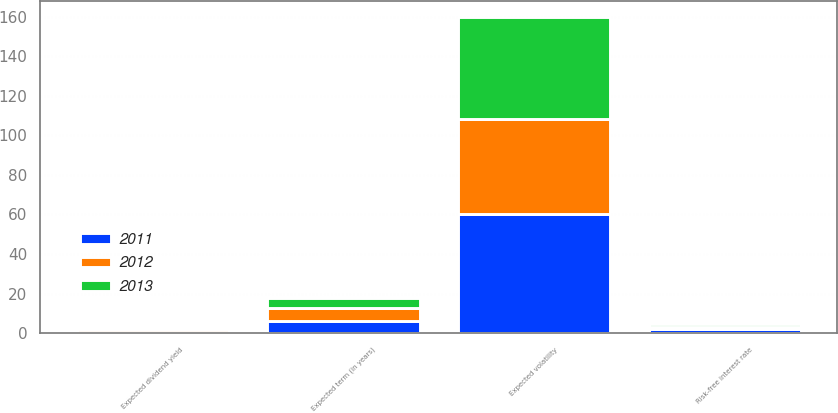<chart> <loc_0><loc_0><loc_500><loc_500><stacked_bar_chart><ecel><fcel>Expected volatility<fcel>Expected dividend yield<fcel>Expected term (in years)<fcel>Risk-free interest rate<nl><fcel>2012<fcel>47.7<fcel>1.74<fcel>7<fcel>0.92<nl><fcel>2013<fcel>51.8<fcel>0.28<fcel>5<fcel>1.46<nl><fcel>2011<fcel>60.46<fcel>0.44<fcel>6<fcel>2.13<nl></chart> 